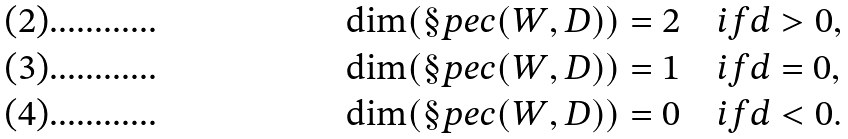<formula> <loc_0><loc_0><loc_500><loc_500>\dim ( \S p e c ( W , D ) ) = 2 \quad & i f d > 0 , \\ \dim ( \S p e c ( W , D ) ) = 1 \quad & i f d = 0 , \\ \dim ( \S p e c ( W , D ) ) = 0 \quad & i f d < 0 .</formula> 